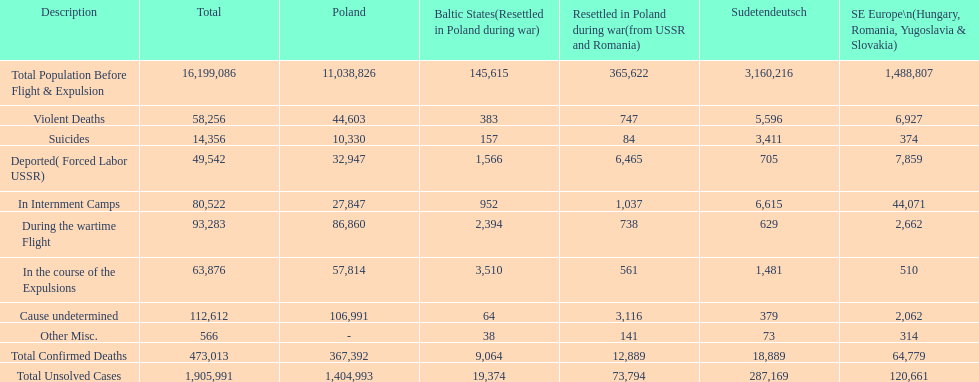Were there more cause undetermined or miscellaneous deaths in the baltic states? Cause undetermined. Help me parse the entirety of this table. {'header': ['Description', 'Total', 'Poland', 'Baltic States(Resettled in Poland during war)', 'Resettled in Poland during war(from USSR and Romania)', 'Sudetendeutsch', 'SE Europe\\n(Hungary, Romania, Yugoslavia & Slovakia)'], 'rows': [['Total Population Before Flight & Expulsion', '16,199,086', '11,038,826', '145,615', '365,622', '3,160,216', '1,488,807'], ['Violent Deaths', '58,256', '44,603', '383', '747', '5,596', '6,927'], ['Suicides', '14,356', '10,330', '157', '84', '3,411', '374'], ['Deported( Forced Labor USSR)', '49,542', '32,947', '1,566', '6,465', '705', '7,859'], ['In Internment Camps', '80,522', '27,847', '952', '1,037', '6,615', '44,071'], ['During the wartime Flight', '93,283', '86,860', '2,394', '738', '629', '2,662'], ['In the course of the Expulsions', '63,876', '57,814', '3,510', '561', '1,481', '510'], ['Cause undetermined', '112,612', '106,991', '64', '3,116', '379', '2,062'], ['Other Misc.', '566', '-', '38', '141', '73', '314'], ['Total Confirmed Deaths', '473,013', '367,392', '9,064', '12,889', '18,889', '64,779'], ['Total Unsolved Cases', '1,905,991', '1,404,993', '19,374', '73,794', '287,169', '120,661']]} 